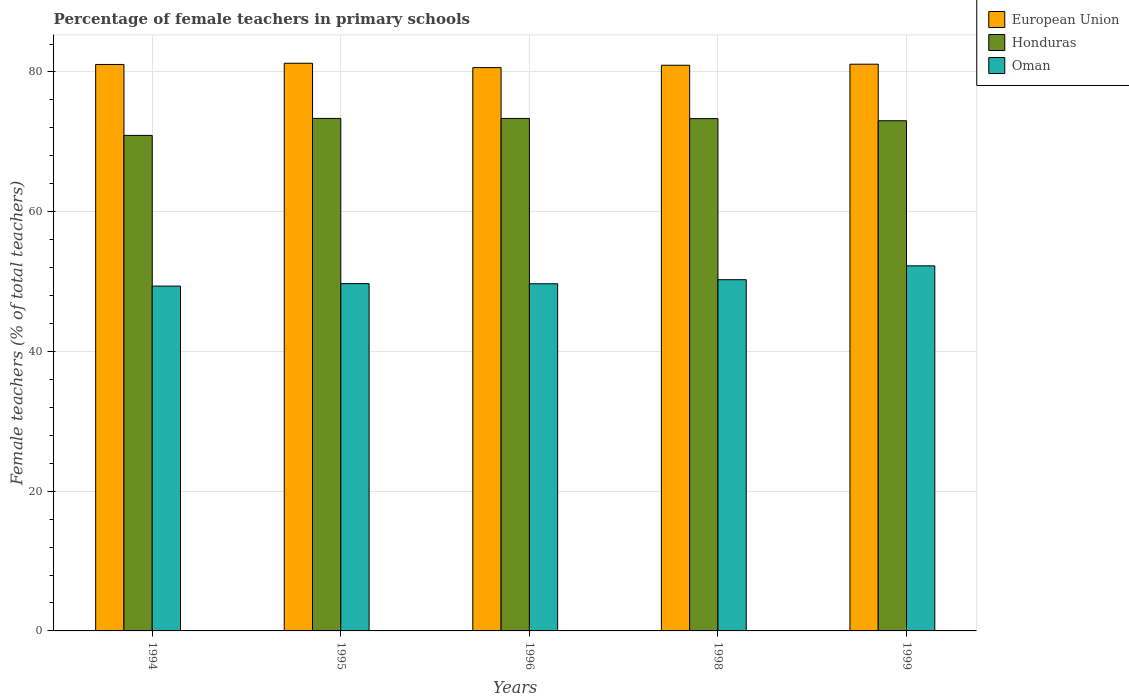How many different coloured bars are there?
Your answer should be very brief. 3. How many bars are there on the 2nd tick from the right?
Provide a short and direct response. 3. What is the label of the 1st group of bars from the left?
Offer a terse response. 1994. In how many cases, is the number of bars for a given year not equal to the number of legend labels?
Offer a terse response. 0. What is the percentage of female teachers in Honduras in 1998?
Offer a very short reply. 73.32. Across all years, what is the maximum percentage of female teachers in Oman?
Provide a short and direct response. 52.25. Across all years, what is the minimum percentage of female teachers in Oman?
Provide a succinct answer. 49.35. What is the total percentage of female teachers in Honduras in the graph?
Give a very brief answer. 363.97. What is the difference between the percentage of female teachers in Oman in 1994 and that in 1998?
Your response must be concise. -0.91. What is the difference between the percentage of female teachers in Honduras in 1999 and the percentage of female teachers in European Union in 1994?
Provide a succinct answer. -8.06. What is the average percentage of female teachers in European Union per year?
Your response must be concise. 81. In the year 1996, what is the difference between the percentage of female teachers in Oman and percentage of female teachers in European Union?
Make the answer very short. -30.94. In how many years, is the percentage of female teachers in Oman greater than 36 %?
Ensure brevity in your answer.  5. What is the ratio of the percentage of female teachers in Honduras in 1994 to that in 1998?
Offer a very short reply. 0.97. Is the percentage of female teachers in European Union in 1995 less than that in 1996?
Provide a short and direct response. No. Is the difference between the percentage of female teachers in Oman in 1994 and 1999 greater than the difference between the percentage of female teachers in European Union in 1994 and 1999?
Keep it short and to the point. No. What is the difference between the highest and the second highest percentage of female teachers in Honduras?
Offer a terse response. 0. What is the difference between the highest and the lowest percentage of female teachers in Honduras?
Offer a very short reply. 2.43. What does the 3rd bar from the left in 1999 represents?
Offer a very short reply. Oman. What does the 1st bar from the right in 1998 represents?
Keep it short and to the point. Oman. Are all the bars in the graph horizontal?
Provide a short and direct response. No. How many years are there in the graph?
Give a very brief answer. 5. What is the difference between two consecutive major ticks on the Y-axis?
Make the answer very short. 20. Are the values on the major ticks of Y-axis written in scientific E-notation?
Offer a very short reply. No. Does the graph contain any zero values?
Keep it short and to the point. No. Where does the legend appear in the graph?
Give a very brief answer. Top right. What is the title of the graph?
Offer a very short reply. Percentage of female teachers in primary schools. Does "Fragile and conflict affected situations" appear as one of the legend labels in the graph?
Your answer should be compact. No. What is the label or title of the X-axis?
Ensure brevity in your answer.  Years. What is the label or title of the Y-axis?
Offer a terse response. Female teachers (% of total teachers). What is the Female teachers (% of total teachers) in European Union in 1994?
Keep it short and to the point. 81.08. What is the Female teachers (% of total teachers) of Honduras in 1994?
Make the answer very short. 70.92. What is the Female teachers (% of total teachers) of Oman in 1994?
Your answer should be very brief. 49.35. What is the Female teachers (% of total teachers) of European Union in 1995?
Keep it short and to the point. 81.25. What is the Female teachers (% of total teachers) of Honduras in 1995?
Ensure brevity in your answer.  73.35. What is the Female teachers (% of total teachers) of Oman in 1995?
Offer a terse response. 49.71. What is the Female teachers (% of total teachers) in European Union in 1996?
Ensure brevity in your answer.  80.62. What is the Female teachers (% of total teachers) in Honduras in 1996?
Keep it short and to the point. 73.35. What is the Female teachers (% of total teachers) of Oman in 1996?
Your answer should be very brief. 49.69. What is the Female teachers (% of total teachers) in European Union in 1998?
Offer a very short reply. 80.96. What is the Female teachers (% of total teachers) in Honduras in 1998?
Your answer should be compact. 73.32. What is the Female teachers (% of total teachers) of Oman in 1998?
Keep it short and to the point. 50.27. What is the Female teachers (% of total teachers) of European Union in 1999?
Your answer should be very brief. 81.11. What is the Female teachers (% of total teachers) of Honduras in 1999?
Provide a succinct answer. 73.02. What is the Female teachers (% of total teachers) of Oman in 1999?
Your response must be concise. 52.25. Across all years, what is the maximum Female teachers (% of total teachers) of European Union?
Ensure brevity in your answer.  81.25. Across all years, what is the maximum Female teachers (% of total teachers) in Honduras?
Your answer should be compact. 73.35. Across all years, what is the maximum Female teachers (% of total teachers) of Oman?
Provide a short and direct response. 52.25. Across all years, what is the minimum Female teachers (% of total teachers) of European Union?
Your answer should be compact. 80.62. Across all years, what is the minimum Female teachers (% of total teachers) in Honduras?
Your answer should be compact. 70.92. Across all years, what is the minimum Female teachers (% of total teachers) of Oman?
Provide a succinct answer. 49.35. What is the total Female teachers (% of total teachers) of European Union in the graph?
Your response must be concise. 405.02. What is the total Female teachers (% of total teachers) of Honduras in the graph?
Offer a terse response. 363.97. What is the total Female teachers (% of total teachers) in Oman in the graph?
Provide a short and direct response. 251.27. What is the difference between the Female teachers (% of total teachers) in European Union in 1994 and that in 1995?
Your response must be concise. -0.17. What is the difference between the Female teachers (% of total teachers) in Honduras in 1994 and that in 1995?
Your response must be concise. -2.43. What is the difference between the Female teachers (% of total teachers) of Oman in 1994 and that in 1995?
Make the answer very short. -0.35. What is the difference between the Female teachers (% of total teachers) in European Union in 1994 and that in 1996?
Provide a succinct answer. 0.45. What is the difference between the Female teachers (% of total teachers) of Honduras in 1994 and that in 1996?
Provide a short and direct response. -2.43. What is the difference between the Female teachers (% of total teachers) in Oman in 1994 and that in 1996?
Offer a terse response. -0.33. What is the difference between the Female teachers (% of total teachers) of European Union in 1994 and that in 1998?
Your response must be concise. 0.11. What is the difference between the Female teachers (% of total teachers) in Honduras in 1994 and that in 1998?
Ensure brevity in your answer.  -2.4. What is the difference between the Female teachers (% of total teachers) in Oman in 1994 and that in 1998?
Make the answer very short. -0.91. What is the difference between the Female teachers (% of total teachers) of European Union in 1994 and that in 1999?
Offer a terse response. -0.04. What is the difference between the Female teachers (% of total teachers) of Honduras in 1994 and that in 1999?
Provide a short and direct response. -2.1. What is the difference between the Female teachers (% of total teachers) in Oman in 1994 and that in 1999?
Your response must be concise. -2.9. What is the difference between the Female teachers (% of total teachers) of European Union in 1995 and that in 1996?
Your response must be concise. 0.62. What is the difference between the Female teachers (% of total teachers) of Honduras in 1995 and that in 1996?
Ensure brevity in your answer.  0. What is the difference between the Female teachers (% of total teachers) in Oman in 1995 and that in 1996?
Provide a succinct answer. 0.02. What is the difference between the Female teachers (% of total teachers) of European Union in 1995 and that in 1998?
Ensure brevity in your answer.  0.28. What is the difference between the Female teachers (% of total teachers) in Honduras in 1995 and that in 1998?
Offer a terse response. 0.03. What is the difference between the Female teachers (% of total teachers) in Oman in 1995 and that in 1998?
Your response must be concise. -0.56. What is the difference between the Female teachers (% of total teachers) in European Union in 1995 and that in 1999?
Your answer should be compact. 0.13. What is the difference between the Female teachers (% of total teachers) in Honduras in 1995 and that in 1999?
Your answer should be compact. 0.33. What is the difference between the Female teachers (% of total teachers) of Oman in 1995 and that in 1999?
Your answer should be very brief. -2.54. What is the difference between the Female teachers (% of total teachers) of European Union in 1996 and that in 1998?
Provide a succinct answer. -0.34. What is the difference between the Female teachers (% of total teachers) in Honduras in 1996 and that in 1998?
Give a very brief answer. 0.03. What is the difference between the Female teachers (% of total teachers) in Oman in 1996 and that in 1998?
Your answer should be compact. -0.58. What is the difference between the Female teachers (% of total teachers) of European Union in 1996 and that in 1999?
Make the answer very short. -0.49. What is the difference between the Female teachers (% of total teachers) of Honduras in 1996 and that in 1999?
Offer a very short reply. 0.33. What is the difference between the Female teachers (% of total teachers) of Oman in 1996 and that in 1999?
Give a very brief answer. -2.56. What is the difference between the Female teachers (% of total teachers) of European Union in 1998 and that in 1999?
Provide a succinct answer. -0.15. What is the difference between the Female teachers (% of total teachers) in Honduras in 1998 and that in 1999?
Your response must be concise. 0.3. What is the difference between the Female teachers (% of total teachers) of Oman in 1998 and that in 1999?
Offer a terse response. -1.98. What is the difference between the Female teachers (% of total teachers) in European Union in 1994 and the Female teachers (% of total teachers) in Honduras in 1995?
Provide a short and direct response. 7.72. What is the difference between the Female teachers (% of total teachers) in European Union in 1994 and the Female teachers (% of total teachers) in Oman in 1995?
Offer a very short reply. 31.37. What is the difference between the Female teachers (% of total teachers) of Honduras in 1994 and the Female teachers (% of total teachers) of Oman in 1995?
Your answer should be compact. 21.22. What is the difference between the Female teachers (% of total teachers) in European Union in 1994 and the Female teachers (% of total teachers) in Honduras in 1996?
Offer a very short reply. 7.72. What is the difference between the Female teachers (% of total teachers) of European Union in 1994 and the Female teachers (% of total teachers) of Oman in 1996?
Keep it short and to the point. 31.39. What is the difference between the Female teachers (% of total teachers) of Honduras in 1994 and the Female teachers (% of total teachers) of Oman in 1996?
Your answer should be very brief. 21.24. What is the difference between the Female teachers (% of total teachers) in European Union in 1994 and the Female teachers (% of total teachers) in Honduras in 1998?
Ensure brevity in your answer.  7.75. What is the difference between the Female teachers (% of total teachers) in European Union in 1994 and the Female teachers (% of total teachers) in Oman in 1998?
Make the answer very short. 30.81. What is the difference between the Female teachers (% of total teachers) of Honduras in 1994 and the Female teachers (% of total teachers) of Oman in 1998?
Offer a terse response. 20.65. What is the difference between the Female teachers (% of total teachers) in European Union in 1994 and the Female teachers (% of total teachers) in Honduras in 1999?
Provide a succinct answer. 8.06. What is the difference between the Female teachers (% of total teachers) of European Union in 1994 and the Female teachers (% of total teachers) of Oman in 1999?
Keep it short and to the point. 28.82. What is the difference between the Female teachers (% of total teachers) in Honduras in 1994 and the Female teachers (% of total teachers) in Oman in 1999?
Provide a short and direct response. 18.67. What is the difference between the Female teachers (% of total teachers) in European Union in 1995 and the Female teachers (% of total teachers) in Honduras in 1996?
Provide a succinct answer. 7.9. What is the difference between the Female teachers (% of total teachers) in European Union in 1995 and the Female teachers (% of total teachers) in Oman in 1996?
Your response must be concise. 31.56. What is the difference between the Female teachers (% of total teachers) in Honduras in 1995 and the Female teachers (% of total teachers) in Oman in 1996?
Your answer should be compact. 23.67. What is the difference between the Female teachers (% of total teachers) in European Union in 1995 and the Female teachers (% of total teachers) in Honduras in 1998?
Provide a succinct answer. 7.92. What is the difference between the Female teachers (% of total teachers) of European Union in 1995 and the Female teachers (% of total teachers) of Oman in 1998?
Provide a short and direct response. 30.98. What is the difference between the Female teachers (% of total teachers) in Honduras in 1995 and the Female teachers (% of total teachers) in Oman in 1998?
Offer a very short reply. 23.08. What is the difference between the Female teachers (% of total teachers) of European Union in 1995 and the Female teachers (% of total teachers) of Honduras in 1999?
Keep it short and to the point. 8.23. What is the difference between the Female teachers (% of total teachers) of European Union in 1995 and the Female teachers (% of total teachers) of Oman in 1999?
Your answer should be very brief. 29. What is the difference between the Female teachers (% of total teachers) in Honduras in 1995 and the Female teachers (% of total teachers) in Oman in 1999?
Offer a terse response. 21.1. What is the difference between the Female teachers (% of total teachers) of European Union in 1996 and the Female teachers (% of total teachers) of Honduras in 1998?
Give a very brief answer. 7.3. What is the difference between the Female teachers (% of total teachers) in European Union in 1996 and the Female teachers (% of total teachers) in Oman in 1998?
Offer a very short reply. 30.35. What is the difference between the Female teachers (% of total teachers) in Honduras in 1996 and the Female teachers (% of total teachers) in Oman in 1998?
Ensure brevity in your answer.  23.08. What is the difference between the Female teachers (% of total teachers) of European Union in 1996 and the Female teachers (% of total teachers) of Honduras in 1999?
Make the answer very short. 7.6. What is the difference between the Female teachers (% of total teachers) of European Union in 1996 and the Female teachers (% of total teachers) of Oman in 1999?
Ensure brevity in your answer.  28.37. What is the difference between the Female teachers (% of total teachers) in Honduras in 1996 and the Female teachers (% of total teachers) in Oman in 1999?
Your answer should be compact. 21.1. What is the difference between the Female teachers (% of total teachers) of European Union in 1998 and the Female teachers (% of total teachers) of Honduras in 1999?
Provide a succinct answer. 7.94. What is the difference between the Female teachers (% of total teachers) in European Union in 1998 and the Female teachers (% of total teachers) in Oman in 1999?
Your response must be concise. 28.71. What is the difference between the Female teachers (% of total teachers) in Honduras in 1998 and the Female teachers (% of total teachers) in Oman in 1999?
Your answer should be compact. 21.07. What is the average Female teachers (% of total teachers) of European Union per year?
Ensure brevity in your answer.  81. What is the average Female teachers (% of total teachers) in Honduras per year?
Offer a very short reply. 72.79. What is the average Female teachers (% of total teachers) of Oman per year?
Give a very brief answer. 50.25. In the year 1994, what is the difference between the Female teachers (% of total teachers) of European Union and Female teachers (% of total teachers) of Honduras?
Provide a succinct answer. 10.15. In the year 1994, what is the difference between the Female teachers (% of total teachers) in European Union and Female teachers (% of total teachers) in Oman?
Give a very brief answer. 31.72. In the year 1994, what is the difference between the Female teachers (% of total teachers) in Honduras and Female teachers (% of total teachers) in Oman?
Provide a short and direct response. 21.57. In the year 1995, what is the difference between the Female teachers (% of total teachers) in European Union and Female teachers (% of total teachers) in Honduras?
Offer a very short reply. 7.89. In the year 1995, what is the difference between the Female teachers (% of total teachers) of European Union and Female teachers (% of total teachers) of Oman?
Make the answer very short. 31.54. In the year 1995, what is the difference between the Female teachers (% of total teachers) in Honduras and Female teachers (% of total teachers) in Oman?
Your answer should be very brief. 23.65. In the year 1996, what is the difference between the Female teachers (% of total teachers) of European Union and Female teachers (% of total teachers) of Honduras?
Offer a very short reply. 7.27. In the year 1996, what is the difference between the Female teachers (% of total teachers) of European Union and Female teachers (% of total teachers) of Oman?
Your response must be concise. 30.94. In the year 1996, what is the difference between the Female teachers (% of total teachers) in Honduras and Female teachers (% of total teachers) in Oman?
Your answer should be very brief. 23.67. In the year 1998, what is the difference between the Female teachers (% of total teachers) of European Union and Female teachers (% of total teachers) of Honduras?
Provide a succinct answer. 7.64. In the year 1998, what is the difference between the Female teachers (% of total teachers) in European Union and Female teachers (% of total teachers) in Oman?
Make the answer very short. 30.69. In the year 1998, what is the difference between the Female teachers (% of total teachers) of Honduras and Female teachers (% of total teachers) of Oman?
Your response must be concise. 23.05. In the year 1999, what is the difference between the Female teachers (% of total teachers) in European Union and Female teachers (% of total teachers) in Honduras?
Keep it short and to the point. 8.09. In the year 1999, what is the difference between the Female teachers (% of total teachers) of European Union and Female teachers (% of total teachers) of Oman?
Keep it short and to the point. 28.86. In the year 1999, what is the difference between the Female teachers (% of total teachers) of Honduras and Female teachers (% of total teachers) of Oman?
Make the answer very short. 20.77. What is the ratio of the Female teachers (% of total teachers) of European Union in 1994 to that in 1995?
Your response must be concise. 1. What is the ratio of the Female teachers (% of total teachers) in Honduras in 1994 to that in 1995?
Provide a succinct answer. 0.97. What is the ratio of the Female teachers (% of total teachers) of Oman in 1994 to that in 1995?
Give a very brief answer. 0.99. What is the ratio of the Female teachers (% of total teachers) of European Union in 1994 to that in 1996?
Provide a short and direct response. 1.01. What is the ratio of the Female teachers (% of total teachers) of Honduras in 1994 to that in 1996?
Offer a very short reply. 0.97. What is the ratio of the Female teachers (% of total teachers) in European Union in 1994 to that in 1998?
Ensure brevity in your answer.  1. What is the ratio of the Female teachers (% of total teachers) in Honduras in 1994 to that in 1998?
Provide a succinct answer. 0.97. What is the ratio of the Female teachers (% of total teachers) of Oman in 1994 to that in 1998?
Give a very brief answer. 0.98. What is the ratio of the Female teachers (% of total teachers) of European Union in 1994 to that in 1999?
Keep it short and to the point. 1. What is the ratio of the Female teachers (% of total teachers) of Honduras in 1994 to that in 1999?
Provide a short and direct response. 0.97. What is the ratio of the Female teachers (% of total teachers) in Oman in 1994 to that in 1999?
Make the answer very short. 0.94. What is the ratio of the Female teachers (% of total teachers) in European Union in 1995 to that in 1996?
Make the answer very short. 1.01. What is the ratio of the Female teachers (% of total teachers) of Oman in 1995 to that in 1996?
Give a very brief answer. 1. What is the ratio of the Female teachers (% of total teachers) in European Union in 1995 to that in 1999?
Give a very brief answer. 1. What is the ratio of the Female teachers (% of total teachers) in Honduras in 1995 to that in 1999?
Your answer should be very brief. 1. What is the ratio of the Female teachers (% of total teachers) of Oman in 1995 to that in 1999?
Your response must be concise. 0.95. What is the ratio of the Female teachers (% of total teachers) in Honduras in 1996 to that in 1998?
Keep it short and to the point. 1. What is the ratio of the Female teachers (% of total teachers) of Oman in 1996 to that in 1998?
Provide a short and direct response. 0.99. What is the ratio of the Female teachers (% of total teachers) of Oman in 1996 to that in 1999?
Your answer should be compact. 0.95. What is the ratio of the Female teachers (% of total teachers) in European Union in 1998 to that in 1999?
Offer a very short reply. 1. What is the ratio of the Female teachers (% of total teachers) in Honduras in 1998 to that in 1999?
Ensure brevity in your answer.  1. What is the ratio of the Female teachers (% of total teachers) of Oman in 1998 to that in 1999?
Provide a short and direct response. 0.96. What is the difference between the highest and the second highest Female teachers (% of total teachers) of European Union?
Give a very brief answer. 0.13. What is the difference between the highest and the second highest Female teachers (% of total teachers) in Honduras?
Give a very brief answer. 0. What is the difference between the highest and the second highest Female teachers (% of total teachers) of Oman?
Your response must be concise. 1.98. What is the difference between the highest and the lowest Female teachers (% of total teachers) in European Union?
Your answer should be very brief. 0.62. What is the difference between the highest and the lowest Female teachers (% of total teachers) in Honduras?
Provide a short and direct response. 2.43. What is the difference between the highest and the lowest Female teachers (% of total teachers) in Oman?
Provide a short and direct response. 2.9. 